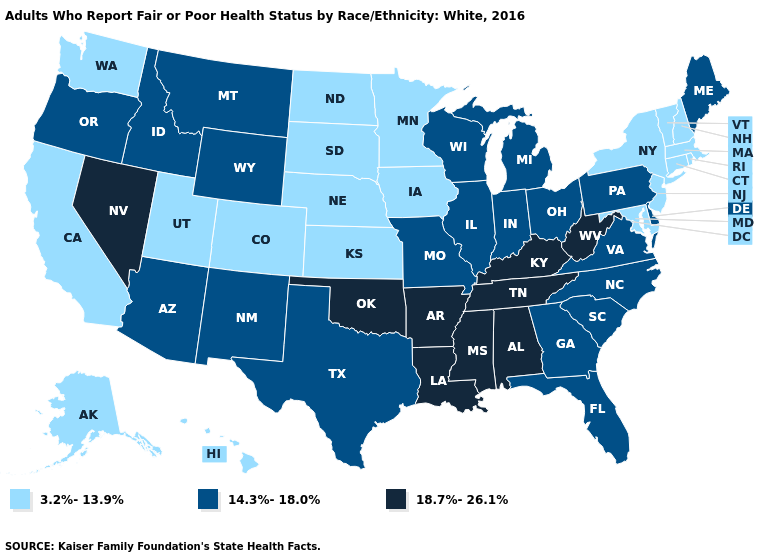What is the value of Nevada?
Concise answer only. 18.7%-26.1%. What is the lowest value in the USA?
Quick response, please. 3.2%-13.9%. Which states have the highest value in the USA?
Keep it brief. Alabama, Arkansas, Kentucky, Louisiana, Mississippi, Nevada, Oklahoma, Tennessee, West Virginia. Which states have the lowest value in the USA?
Write a very short answer. Alaska, California, Colorado, Connecticut, Hawaii, Iowa, Kansas, Maryland, Massachusetts, Minnesota, Nebraska, New Hampshire, New Jersey, New York, North Dakota, Rhode Island, South Dakota, Utah, Vermont, Washington. Name the states that have a value in the range 14.3%-18.0%?
Answer briefly. Arizona, Delaware, Florida, Georgia, Idaho, Illinois, Indiana, Maine, Michigan, Missouri, Montana, New Mexico, North Carolina, Ohio, Oregon, Pennsylvania, South Carolina, Texas, Virginia, Wisconsin, Wyoming. Name the states that have a value in the range 14.3%-18.0%?
Short answer required. Arizona, Delaware, Florida, Georgia, Idaho, Illinois, Indiana, Maine, Michigan, Missouri, Montana, New Mexico, North Carolina, Ohio, Oregon, Pennsylvania, South Carolina, Texas, Virginia, Wisconsin, Wyoming. Which states have the highest value in the USA?
Write a very short answer. Alabama, Arkansas, Kentucky, Louisiana, Mississippi, Nevada, Oklahoma, Tennessee, West Virginia. Is the legend a continuous bar?
Short answer required. No. Name the states that have a value in the range 14.3%-18.0%?
Be succinct. Arizona, Delaware, Florida, Georgia, Idaho, Illinois, Indiana, Maine, Michigan, Missouri, Montana, New Mexico, North Carolina, Ohio, Oregon, Pennsylvania, South Carolina, Texas, Virginia, Wisconsin, Wyoming. Does the first symbol in the legend represent the smallest category?
Short answer required. Yes. Which states have the lowest value in the South?
Concise answer only. Maryland. What is the value of Kansas?
Quick response, please. 3.2%-13.9%. What is the value of Missouri?
Answer briefly. 14.3%-18.0%. Does Nevada have the highest value in the West?
Write a very short answer. Yes. Is the legend a continuous bar?
Short answer required. No. 